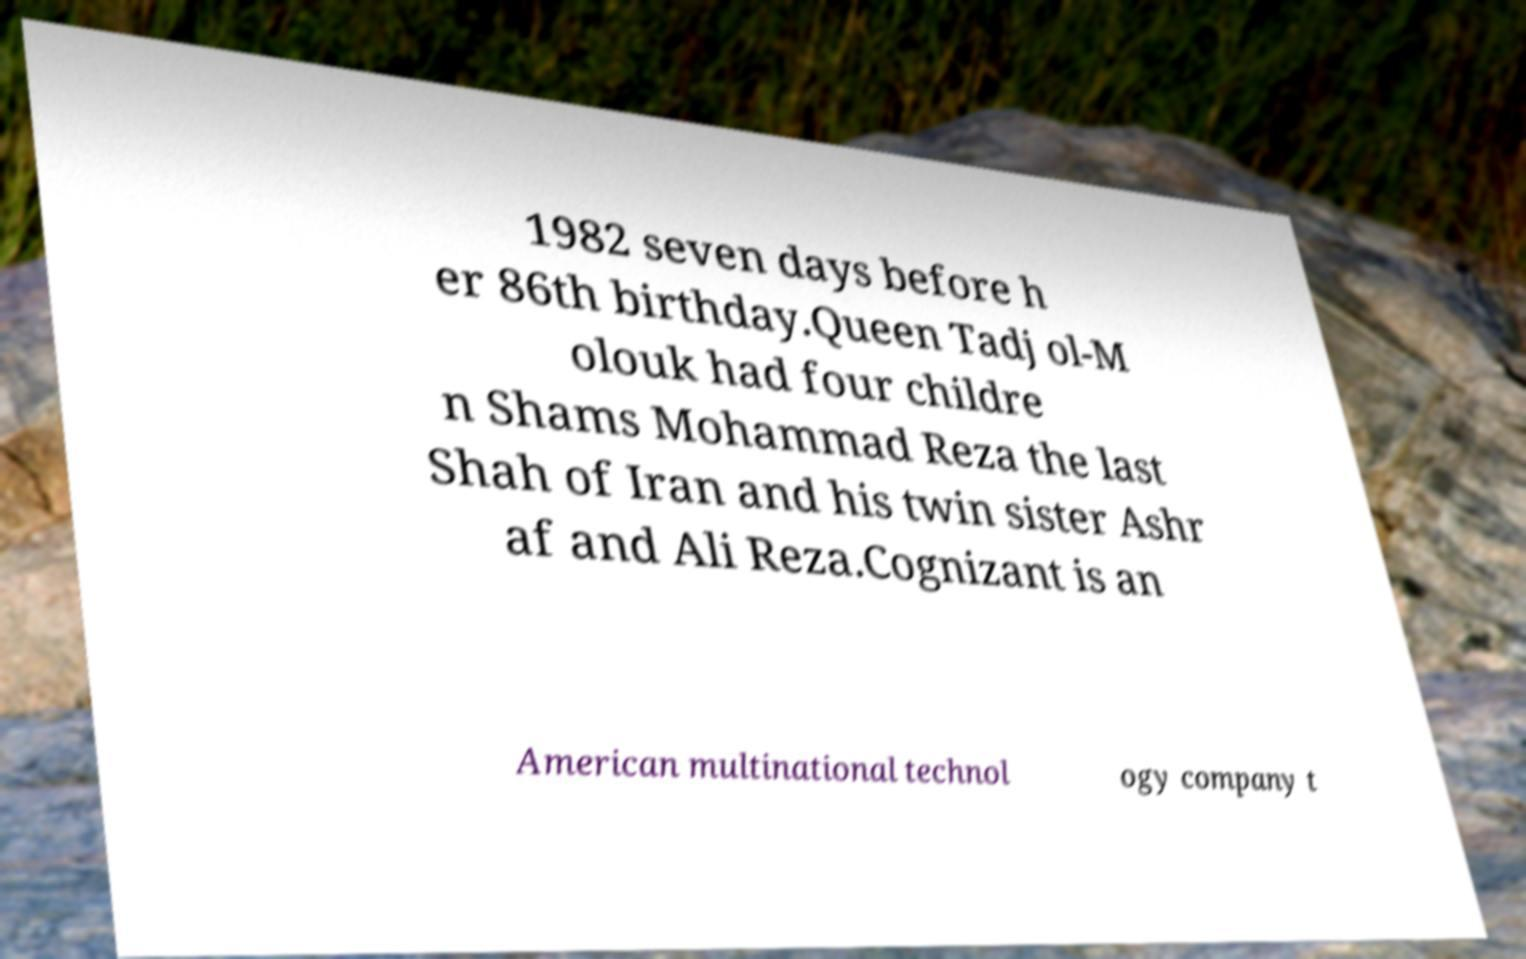Could you assist in decoding the text presented in this image and type it out clearly? 1982 seven days before h er 86th birthday.Queen Tadj ol-M olouk had four childre n Shams Mohammad Reza the last Shah of Iran and his twin sister Ashr af and Ali Reza.Cognizant is an American multinational technol ogy company t 